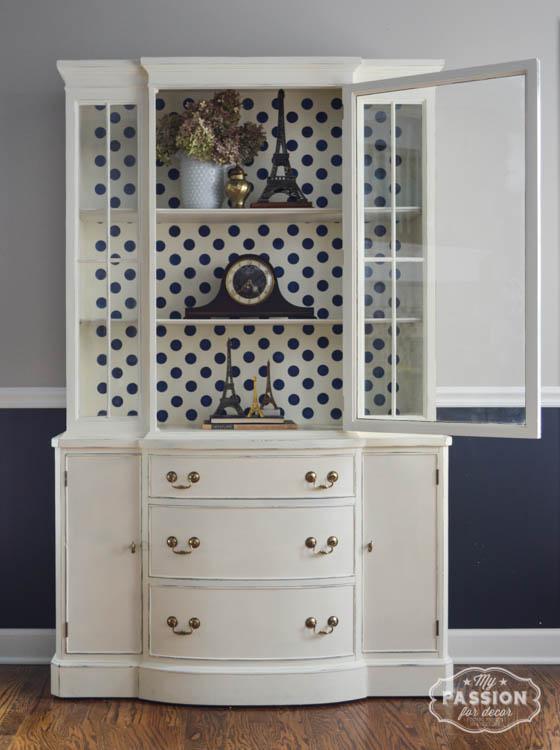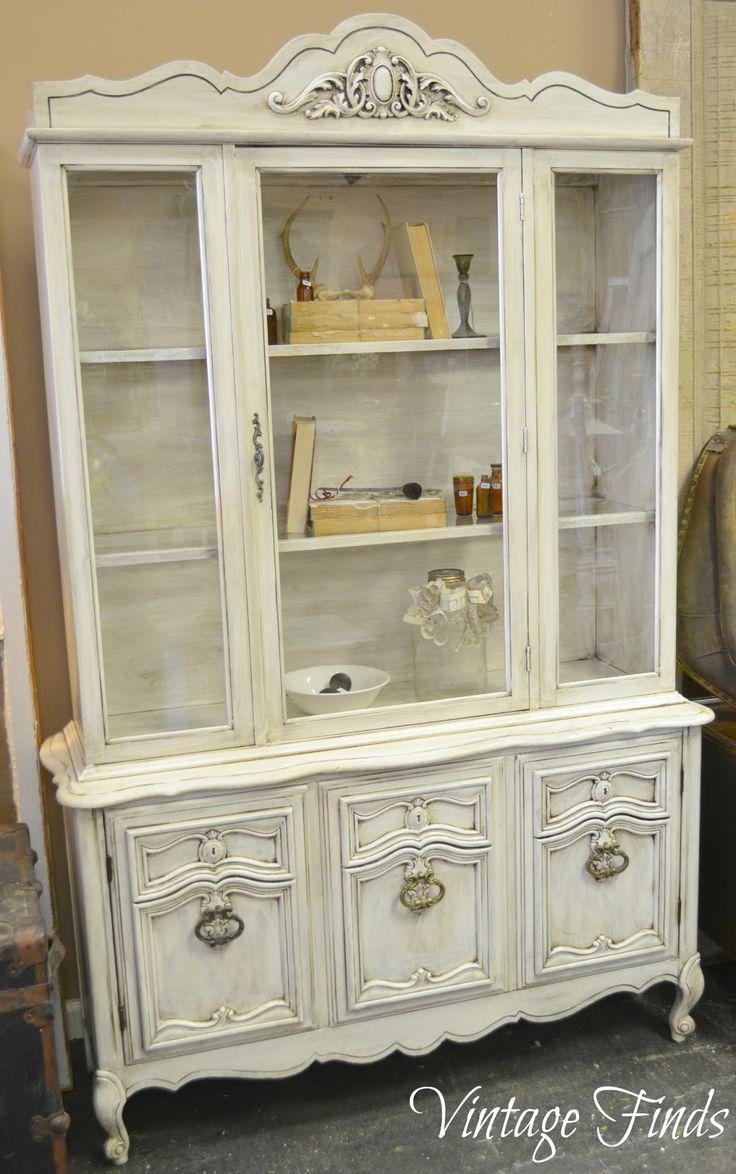The first image is the image on the left, the second image is the image on the right. Considering the images on both sides, is "The teal cabinet has exactly three lower drawers." valid? Answer yes or no. No. The first image is the image on the left, the second image is the image on the right. Evaluate the accuracy of this statement regarding the images: "AN image shows a flat-topped cabinet above a three stacked drawer section that is not flat.". Is it true? Answer yes or no. Yes. 